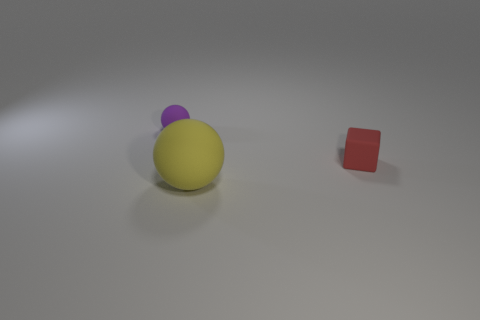Add 2 tiny purple spheres. How many objects exist? 5 Subtract all spheres. How many objects are left? 1 Subtract 0 gray cubes. How many objects are left? 3 Subtract all purple rubber balls. Subtract all tiny red objects. How many objects are left? 1 Add 2 tiny rubber cubes. How many tiny rubber cubes are left? 3 Add 1 small purple cubes. How many small purple cubes exist? 1 